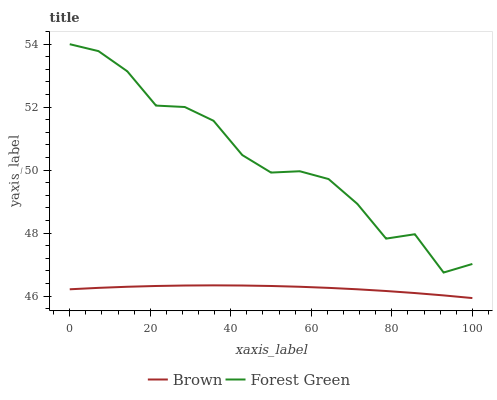Does Brown have the minimum area under the curve?
Answer yes or no. Yes. Does Forest Green have the maximum area under the curve?
Answer yes or no. Yes. Does Forest Green have the minimum area under the curve?
Answer yes or no. No. Is Brown the smoothest?
Answer yes or no. Yes. Is Forest Green the roughest?
Answer yes or no. Yes. Is Forest Green the smoothest?
Answer yes or no. No. Does Forest Green have the lowest value?
Answer yes or no. No. Does Forest Green have the highest value?
Answer yes or no. Yes. Is Brown less than Forest Green?
Answer yes or no. Yes. Is Forest Green greater than Brown?
Answer yes or no. Yes. Does Brown intersect Forest Green?
Answer yes or no. No. 